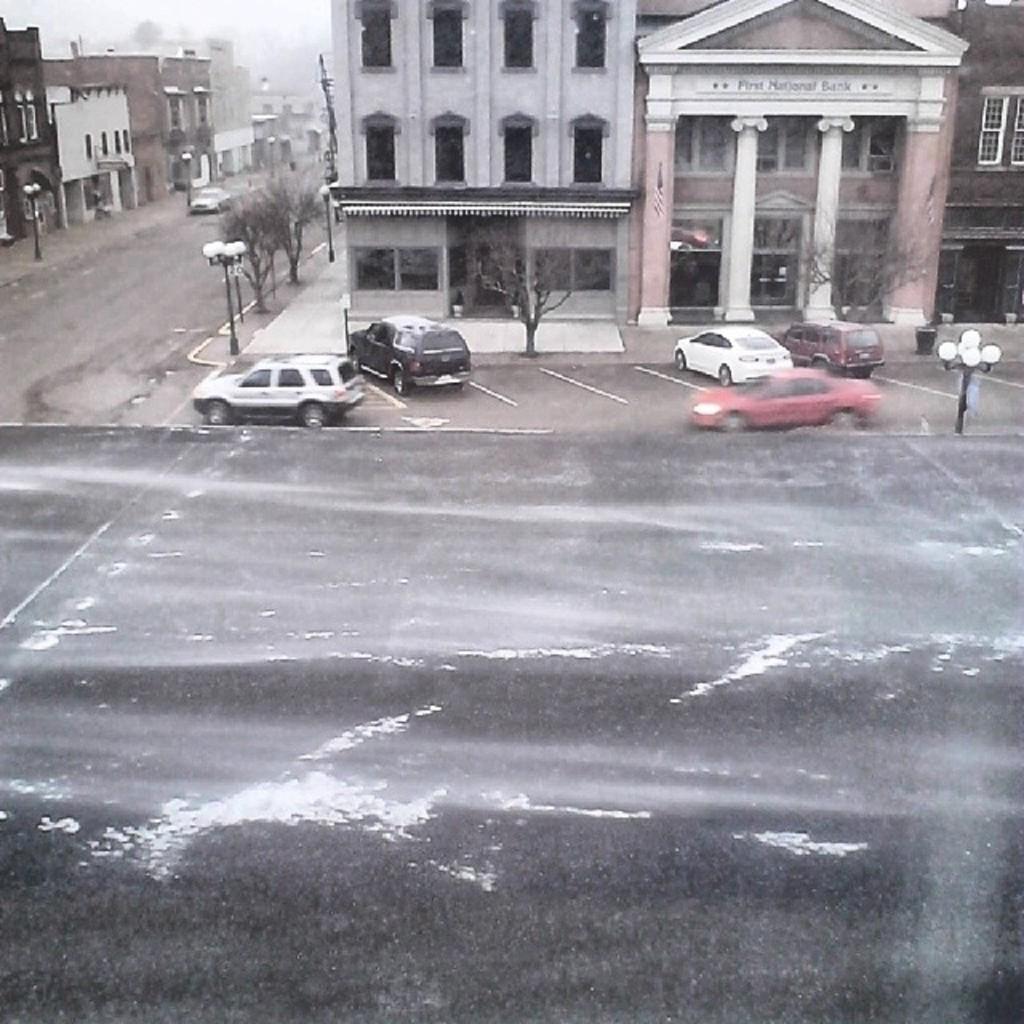How would you summarize this image in a sentence or two? As we can see in the image there are few buildings, in between building there is a road, in front of buildings there are cars, dry trees and street lamps. 